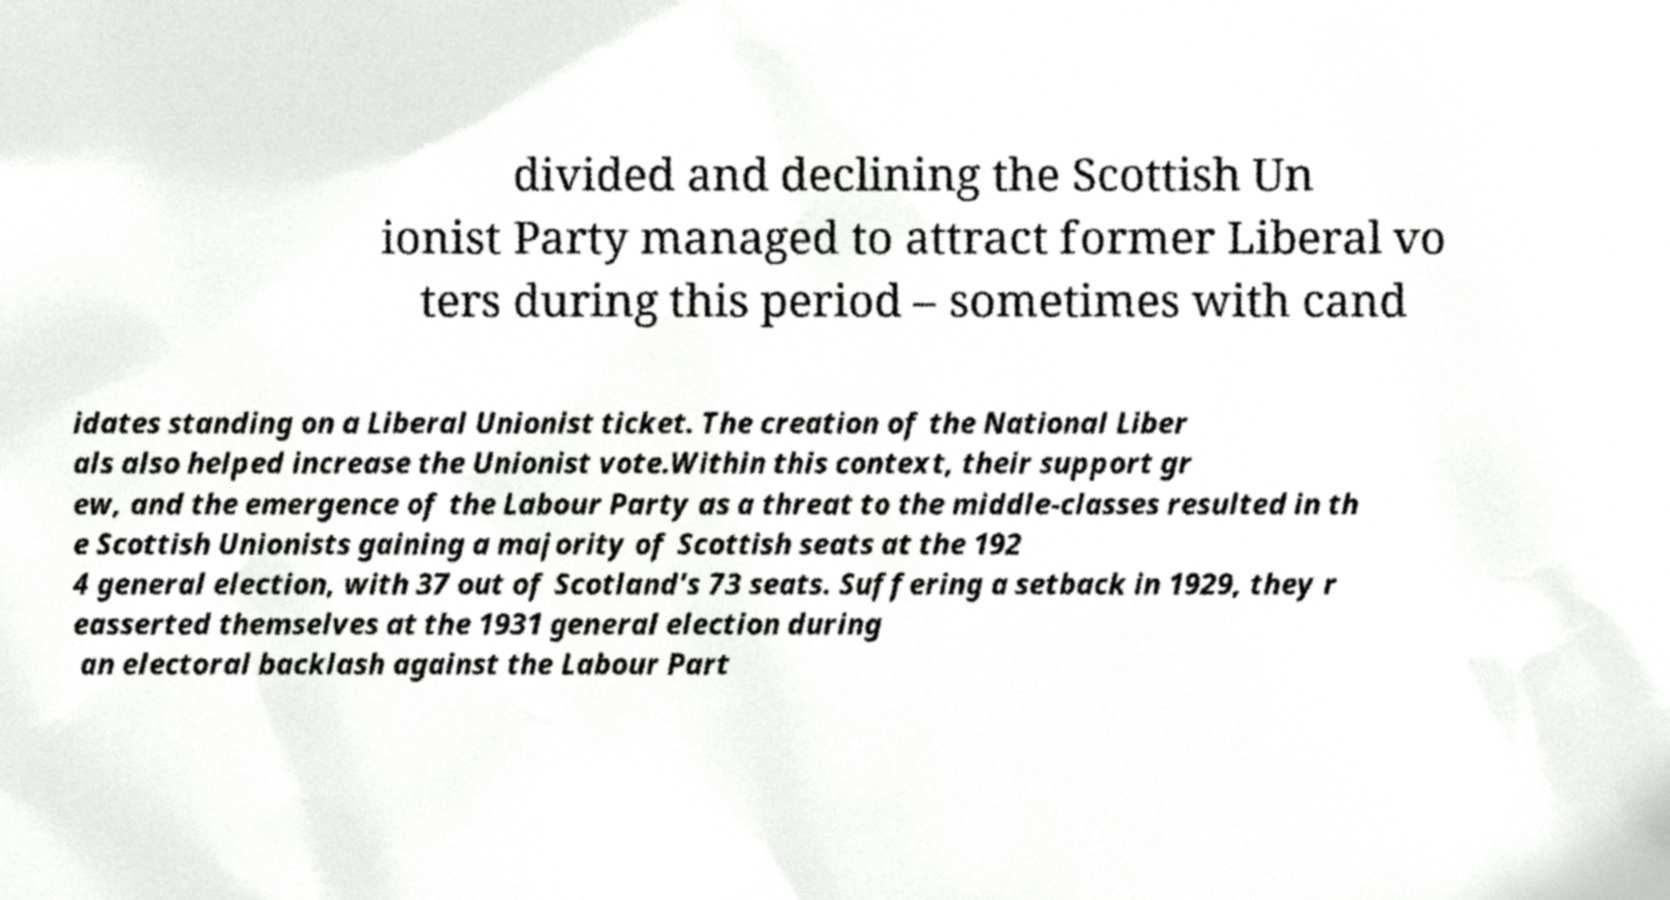Could you assist in decoding the text presented in this image and type it out clearly? divided and declining the Scottish Un ionist Party managed to attract former Liberal vo ters during this period – sometimes with cand idates standing on a Liberal Unionist ticket. The creation of the National Liber als also helped increase the Unionist vote.Within this context, their support gr ew, and the emergence of the Labour Party as a threat to the middle-classes resulted in th e Scottish Unionists gaining a majority of Scottish seats at the 192 4 general election, with 37 out of Scotland's 73 seats. Suffering a setback in 1929, they r easserted themselves at the 1931 general election during an electoral backlash against the Labour Part 